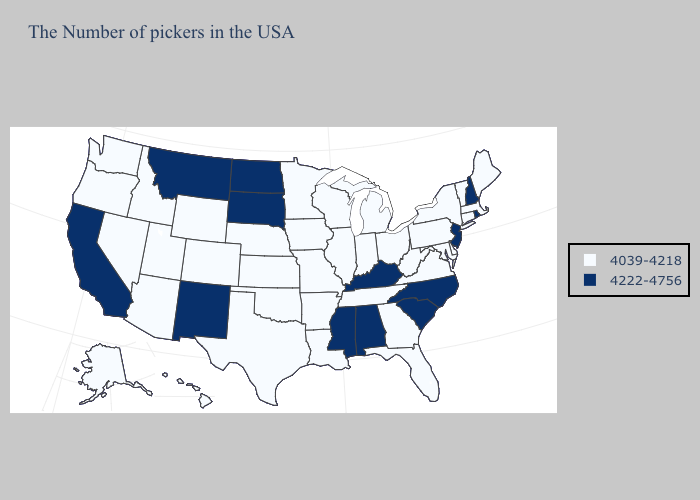Name the states that have a value in the range 4039-4218?
Write a very short answer. Maine, Massachusetts, Vermont, Connecticut, New York, Delaware, Maryland, Pennsylvania, Virginia, West Virginia, Ohio, Florida, Georgia, Michigan, Indiana, Tennessee, Wisconsin, Illinois, Louisiana, Missouri, Arkansas, Minnesota, Iowa, Kansas, Nebraska, Oklahoma, Texas, Wyoming, Colorado, Utah, Arizona, Idaho, Nevada, Washington, Oregon, Alaska, Hawaii. What is the lowest value in the Northeast?
Give a very brief answer. 4039-4218. Does the map have missing data?
Keep it brief. No. Does Louisiana have the lowest value in the South?
Quick response, please. Yes. Which states have the lowest value in the USA?
Concise answer only. Maine, Massachusetts, Vermont, Connecticut, New York, Delaware, Maryland, Pennsylvania, Virginia, West Virginia, Ohio, Florida, Georgia, Michigan, Indiana, Tennessee, Wisconsin, Illinois, Louisiana, Missouri, Arkansas, Minnesota, Iowa, Kansas, Nebraska, Oklahoma, Texas, Wyoming, Colorado, Utah, Arizona, Idaho, Nevada, Washington, Oregon, Alaska, Hawaii. What is the value of Delaware?
Give a very brief answer. 4039-4218. What is the highest value in the USA?
Keep it brief. 4222-4756. What is the value of New Jersey?
Short answer required. 4222-4756. Name the states that have a value in the range 4039-4218?
Write a very short answer. Maine, Massachusetts, Vermont, Connecticut, New York, Delaware, Maryland, Pennsylvania, Virginia, West Virginia, Ohio, Florida, Georgia, Michigan, Indiana, Tennessee, Wisconsin, Illinois, Louisiana, Missouri, Arkansas, Minnesota, Iowa, Kansas, Nebraska, Oklahoma, Texas, Wyoming, Colorado, Utah, Arizona, Idaho, Nevada, Washington, Oregon, Alaska, Hawaii. Which states have the highest value in the USA?
Give a very brief answer. Rhode Island, New Hampshire, New Jersey, North Carolina, South Carolina, Kentucky, Alabama, Mississippi, South Dakota, North Dakota, New Mexico, Montana, California. Does the map have missing data?
Be succinct. No. What is the value of Georgia?
Give a very brief answer. 4039-4218. Name the states that have a value in the range 4039-4218?
Quick response, please. Maine, Massachusetts, Vermont, Connecticut, New York, Delaware, Maryland, Pennsylvania, Virginia, West Virginia, Ohio, Florida, Georgia, Michigan, Indiana, Tennessee, Wisconsin, Illinois, Louisiana, Missouri, Arkansas, Minnesota, Iowa, Kansas, Nebraska, Oklahoma, Texas, Wyoming, Colorado, Utah, Arizona, Idaho, Nevada, Washington, Oregon, Alaska, Hawaii. What is the value of Utah?
Quick response, please. 4039-4218. 